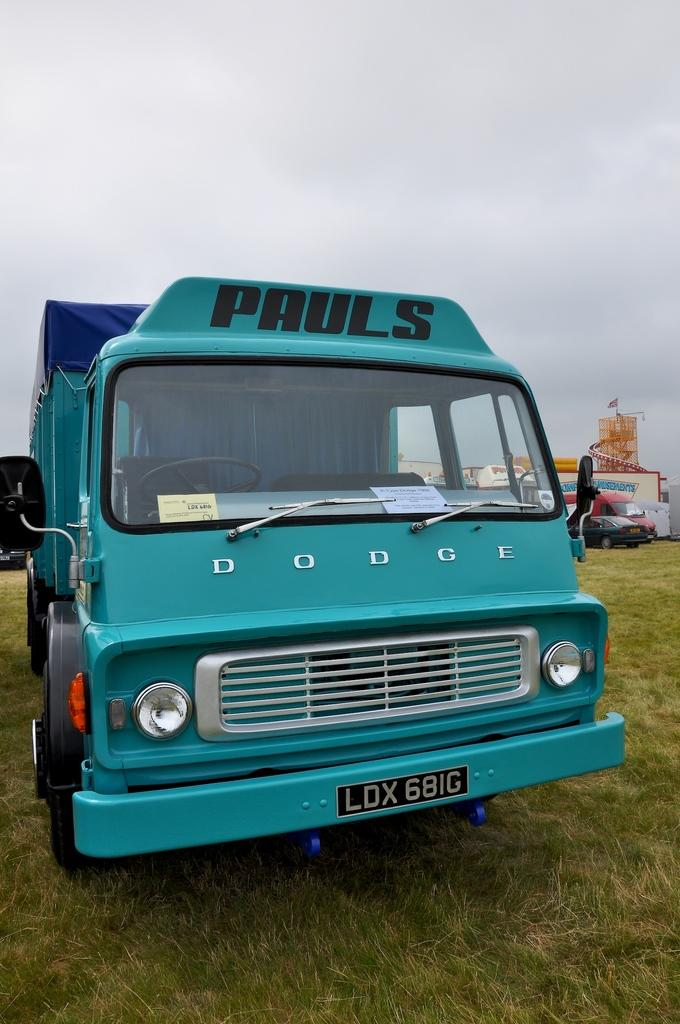What is the main subject of the image? There is a vehicle in the image. Can you describe the color of the vehicle? The vehicle is green. Are there any other vehicles visible in the image? Yes, there are other vehicles visible in the background. What is the color of the sky in the image? The sky is white in color. What type of zinc is used to build the vehicles in the image? There is no information about the materials used to build the vehicles in the image, and zinc is not mentioned in the provided facts. 